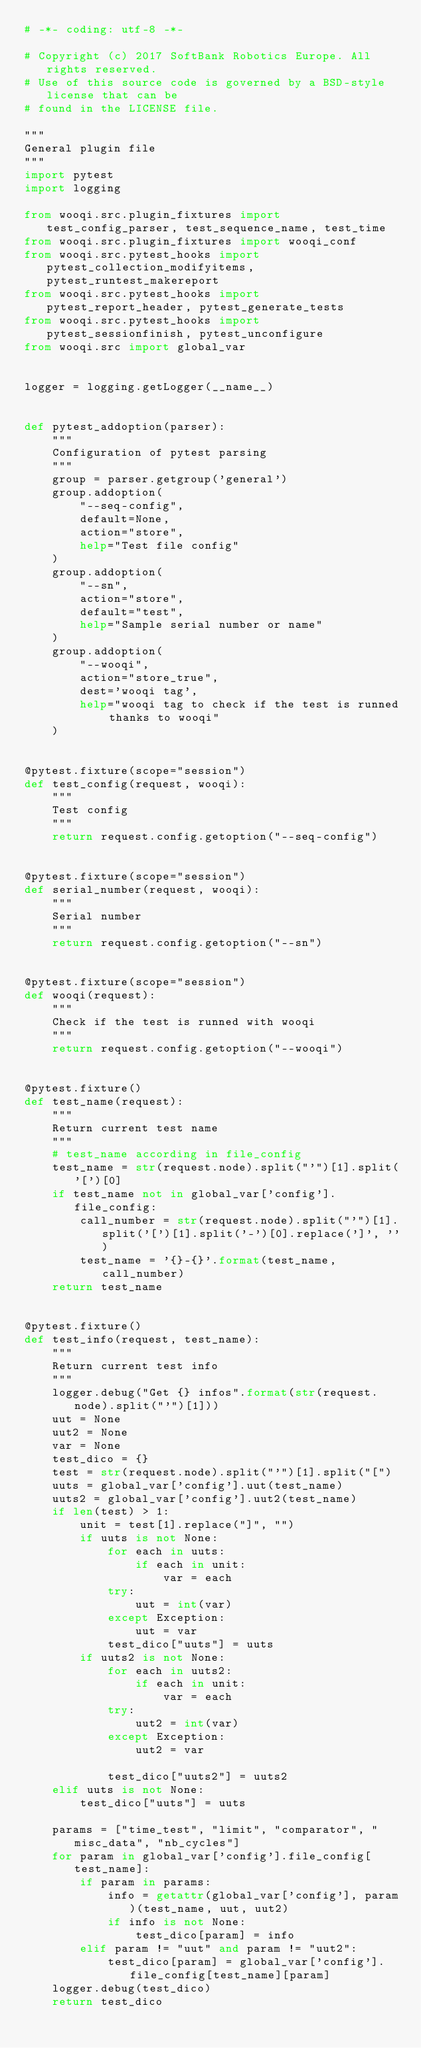<code> <loc_0><loc_0><loc_500><loc_500><_Python_># -*- coding: utf-8 -*-

# Copyright (c) 2017 SoftBank Robotics Europe. All rights reserved.
# Use of this source code is governed by a BSD-style license that can be
# found in the LICENSE file.

"""
General plugin file
"""
import pytest
import logging

from wooqi.src.plugin_fixtures import test_config_parser, test_sequence_name, test_time
from wooqi.src.plugin_fixtures import wooqi_conf
from wooqi.src.pytest_hooks import pytest_collection_modifyitems, pytest_runtest_makereport
from wooqi.src.pytest_hooks import pytest_report_header, pytest_generate_tests
from wooqi.src.pytest_hooks import pytest_sessionfinish, pytest_unconfigure
from wooqi.src import global_var


logger = logging.getLogger(__name__)


def pytest_addoption(parser):
    """
    Configuration of pytest parsing
    """
    group = parser.getgroup('general')
    group.addoption(
        "--seq-config",
        default=None,
        action="store",
        help="Test file config"
    )
    group.addoption(
        "--sn",
        action="store",
        default="test",
        help="Sample serial number or name"
    )
    group.addoption(
        "--wooqi",
        action="store_true",
        dest='wooqi tag',
        help="wooqi tag to check if the test is runned thanks to wooqi"
    )


@pytest.fixture(scope="session")
def test_config(request, wooqi):
    """
    Test config
    """
    return request.config.getoption("--seq-config")


@pytest.fixture(scope="session")
def serial_number(request, wooqi):
    """
    Serial number
    """
    return request.config.getoption("--sn")


@pytest.fixture(scope="session")
def wooqi(request):
    """
    Check if the test is runned with wooqi
    """
    return request.config.getoption("--wooqi")


@pytest.fixture()
def test_name(request):
    """
    Return current test name
    """
    # test_name according in file_config
    test_name = str(request.node).split("'")[1].split('[')[0]
    if test_name not in global_var['config'].file_config:
        call_number = str(request.node).split("'")[1].split('[')[1].split('-')[0].replace(']', '')
        test_name = '{}-{}'.format(test_name, call_number)
    return test_name


@pytest.fixture()
def test_info(request, test_name):
    """
    Return current test info
    """
    logger.debug("Get {} infos".format(str(request.node).split("'")[1]))
    uut = None
    uut2 = None
    var = None
    test_dico = {}
    test = str(request.node).split("'")[1].split("[")
    uuts = global_var['config'].uut(test_name)
    uuts2 = global_var['config'].uut2(test_name)
    if len(test) > 1:
        unit = test[1].replace("]", "")
        if uuts is not None:
            for each in uuts:
                if each in unit:
                    var = each
            try:
                uut = int(var)
            except Exception:
                uut = var
            test_dico["uuts"] = uuts
        if uuts2 is not None:
            for each in uuts2:
                if each in unit:
                    var = each
            try:
                uut2 = int(var)
            except Exception:
                uut2 = var

            test_dico["uuts2"] = uuts2
    elif uuts is not None:
        test_dico["uuts"] = uuts

    params = ["time_test", "limit", "comparator", "misc_data", "nb_cycles"]
    for param in global_var['config'].file_config[test_name]:
        if param in params:
            info = getattr(global_var['config'], param)(test_name, uut, uut2)
            if info is not None:
                test_dico[param] = info
        elif param != "uut" and param != "uut2":
            test_dico[param] = global_var['config'].file_config[test_name][param]
    logger.debug(test_dico)
    return test_dico
</code> 